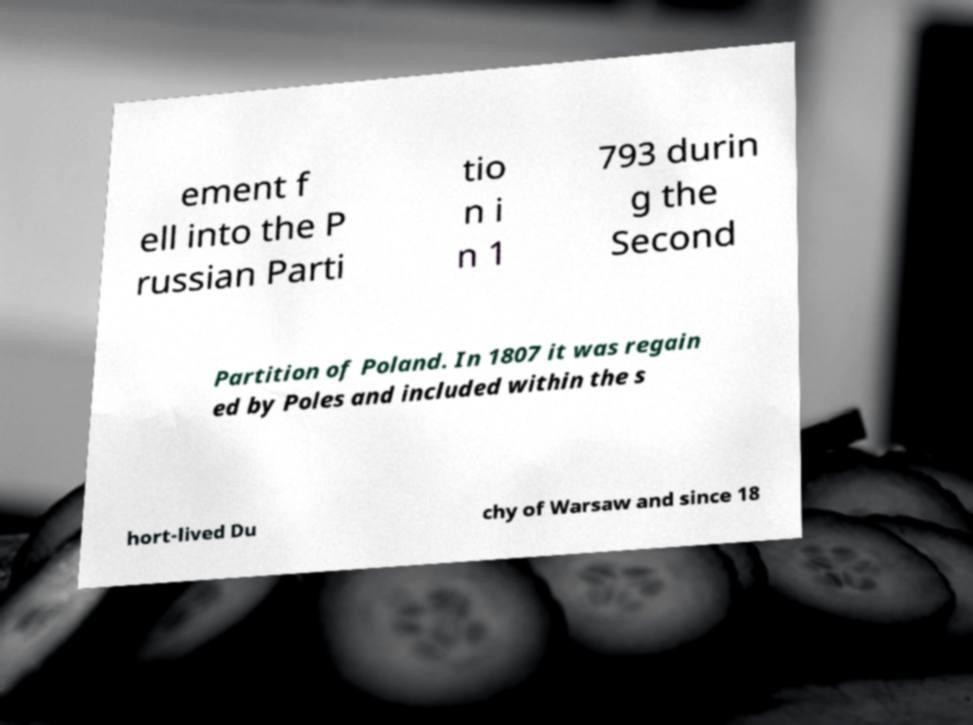Please identify and transcribe the text found in this image. ement f ell into the P russian Parti tio n i n 1 793 durin g the Second Partition of Poland. In 1807 it was regain ed by Poles and included within the s hort-lived Du chy of Warsaw and since 18 